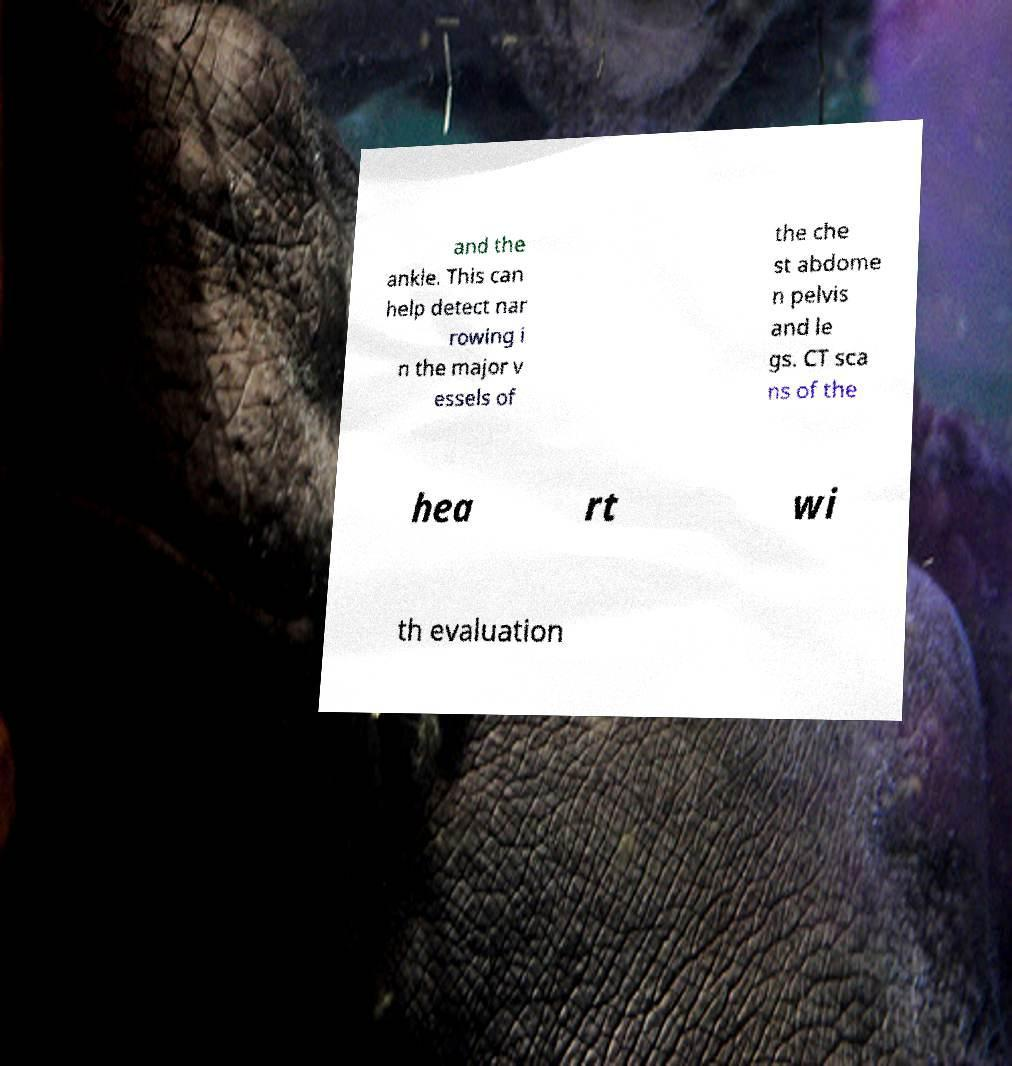I need the written content from this picture converted into text. Can you do that? and the ankle. This can help detect nar rowing i n the major v essels of the che st abdome n pelvis and le gs. CT sca ns of the hea rt wi th evaluation 